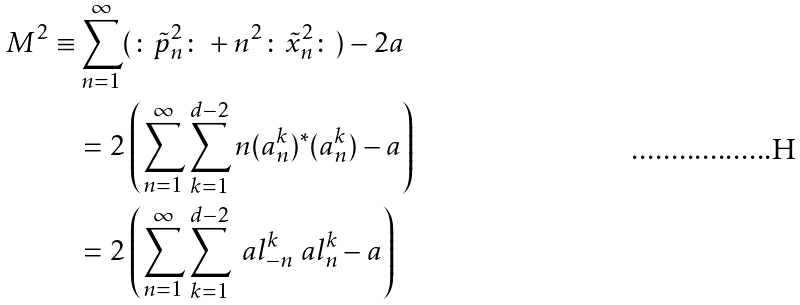Convert formula to latex. <formula><loc_0><loc_0><loc_500><loc_500>M ^ { 2 } \equiv & \sum _ { n = 1 } ^ { \infty } ( \colon \tilde { p } _ { n } ^ { 2 } \colon + n ^ { 2 } \colon \tilde { x } _ { n } ^ { 2 } \colon ) - 2 a \\ & = 2 \left ( \sum _ { n = 1 } ^ { \infty } \sum _ { k = 1 } ^ { d - 2 } n ( a ^ { k } _ { n } ) ^ { * } ( a ^ { k } _ { n } ) - a \right ) \\ & = 2 \left ( \sum _ { n = 1 } ^ { \infty } \sum _ { k = 1 } ^ { d - 2 } \ a l _ { - n } ^ { k } \ a l _ { n } ^ { k } - a \right ) \\</formula> 